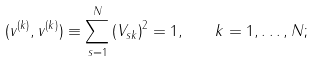<formula> <loc_0><loc_0><loc_500><loc_500>( v ^ { ( k ) } , v ^ { ( k ) } ) \equiv \sum _ { s = 1 } ^ { N } \left ( V _ { s k } \right ) ^ { 2 } = 1 , \quad k = 1 , \dots , N ;</formula> 